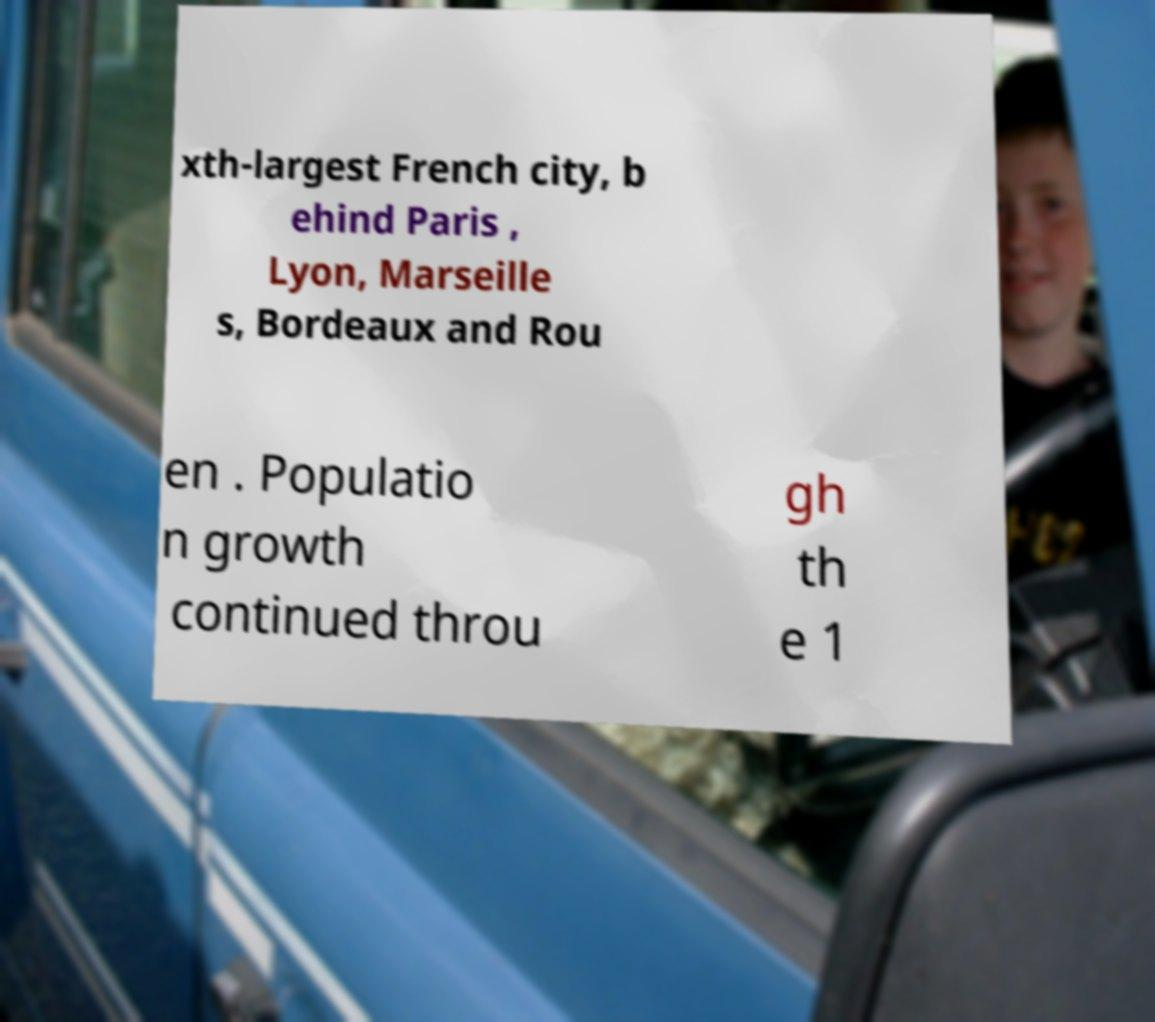Can you accurately transcribe the text from the provided image for me? xth-largest French city, b ehind Paris , Lyon, Marseille s, Bordeaux and Rou en . Populatio n growth continued throu gh th e 1 